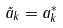<formula> <loc_0><loc_0><loc_500><loc_500>\tilde { a } _ { k } = a _ { k } ^ { * }</formula> 